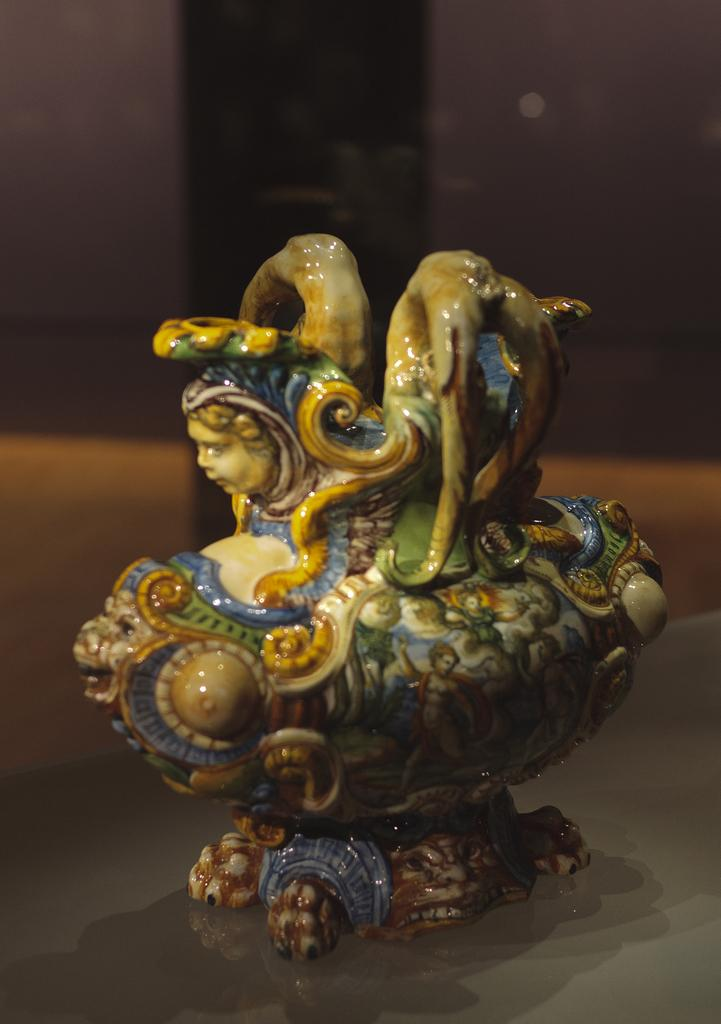What is the main object in the image? There is a ceramic showpiece in the image. Where is the showpiece located? The showpiece is placed on a table. Can you describe the background of the image? The background of the image is blurred. How many bubbles can be seen around the ceramic showpiece in the image? There are no bubbles present in the image. What type of board is placed next to the ceramic showpiece in the image? There is no board present in the image. 